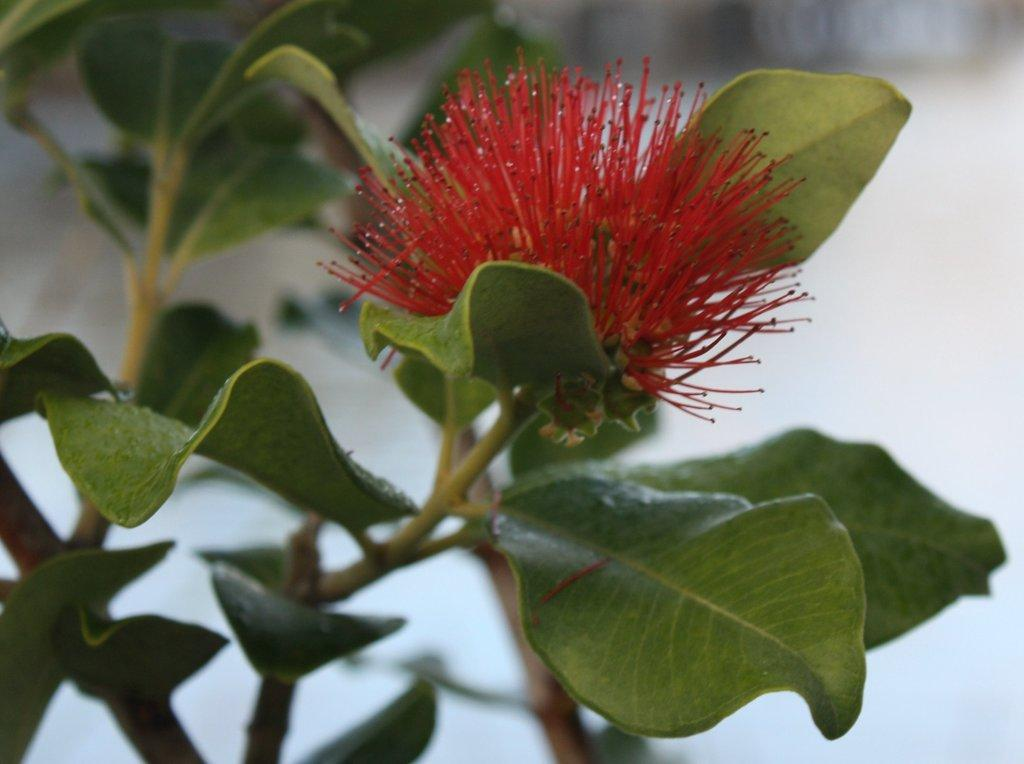What type of plant is visible in the image? There is a plant with a flower in the image. Can you describe the background of the image? The background of the image is blurred. How many frogs can be seen sitting on the drain in the image? There are no frogs or drains present in the image. 